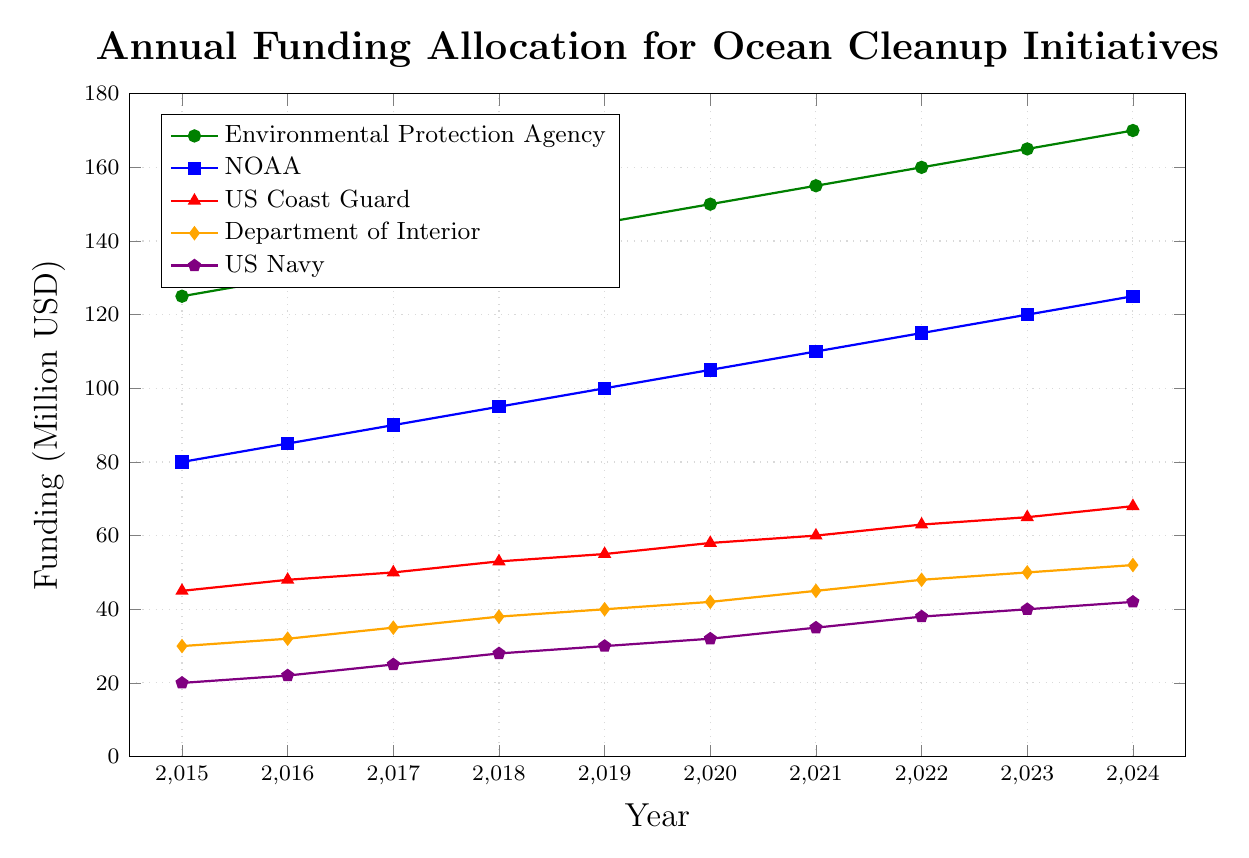When did the Environmental Protection Agency (EPA) reach the funding level of 150 million USD for the first time? To determine when the EPA first reached a funding level of 150 million USD, we look at the trend line for the EPA and identify the year where the funding amount is exactly 150 million USD. According to the figure, this occurs in the year 2020.
Answer: 2020 Which agency had the highest funding allocation in 2024? To answer this, we look at the data points for the year 2024 and compare the funding levels of all the agencies. The agency with the highest funding allocation in 2024 is the Environmental Protection Agency with 170 million USD.
Answer: Environmental Protection Agency What is the total funding allocation for all agencies in 2023? Sum the funding allocations of all the agencies for the year 2023: EPA (165) + NOAA (120) + US Coast Guard (65) + Department of Interior (50) + US Navy (40). Thus, 165 + 120 + 65 + 50 + 40 = 440 million USD.
Answer: 440 million USD Between which two consecutive years did the NOAA see the largest increase in funding? To find the largest increase in funding for NOAA, subtract the prior year’s funding from the current year’s funding for each consecutive year and identify the maximum increase. The largest annual increase is from 2019 to 2020: 105 - 100 = 5 million USD.
Answer: 2019 and 2020 By how much did the funding for the US Coast Guard increase from 2015 to 2024? Subtract the funding level in 2015 from the funding level in 2024 for the US Coast Guard. This is 68 - 45 = 23 million USD.
Answer: 23 million USD Which agency saw the least growth in funding from 2015 to 2024 in absolute terms? To determine the least growth, subtract the 2015 funding from the 2024 funding for each agency and compare the differences. The US Navy had the least growth: 42 - 20 = 22 million USD.
Answer: US Navy How does the funding trend for the Department of Interior compare to that of the US Coast Guard over the years? To compare trends, look at the gradient of the lines representing each agency. Both show a consistent increase over the years, but we need to compare the overall rise. From 2015 to 2024, the Department of Interior increased from 30 to 52 (22 million USD), and US Coast Guard increased from 45 to 68 (23 million USD). Thus, they have very similar trends.
Answer: Similar trends but US Coast Guard slightly higher What is the average annual funding increase for NOAA between 2015 and 2024? First, calculate the total increase from 2015 to 2024: 125 - 80 = 45 million USD. Then divide this increase by the number of years (2024 - 2015 = 9 years). Therefore, the average annual increase is 45 / 9 = 5 million USD per year.
Answer: 5 million USD per year In 2021, which agency had a funding level closest to 60 million USD? Compare the funding levels of all the agencies in 2021 to find the one nearest to 60 million USD. The US Coast Guard had a funding level of 60 million USD, exactly matching it.
Answer: US Coast Guard 